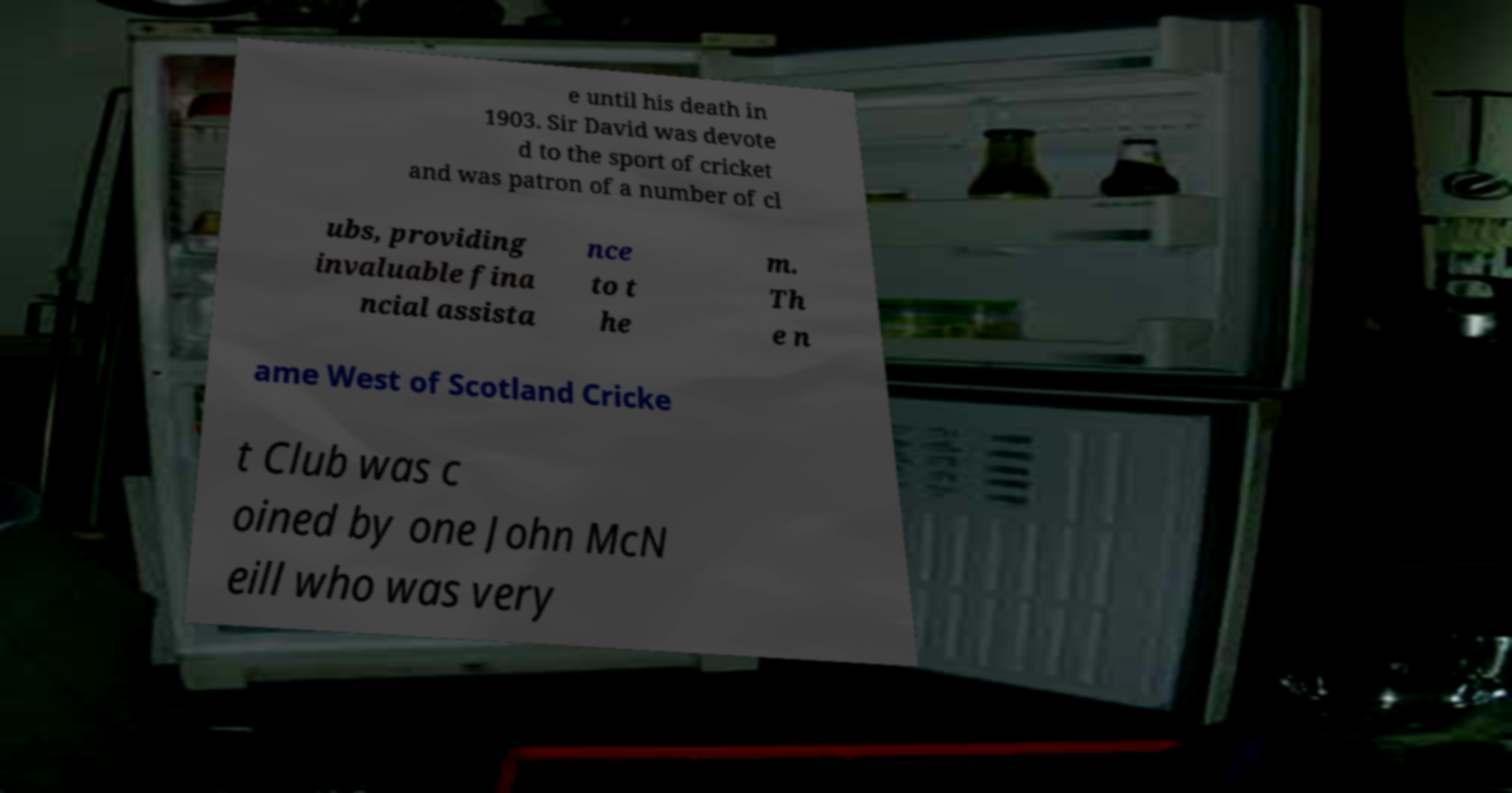Could you extract and type out the text from this image? e until his death in 1903. Sir David was devote d to the sport of cricket and was patron of a number of cl ubs, providing invaluable fina ncial assista nce to t he m. Th e n ame West of Scotland Cricke t Club was c oined by one John McN eill who was very 